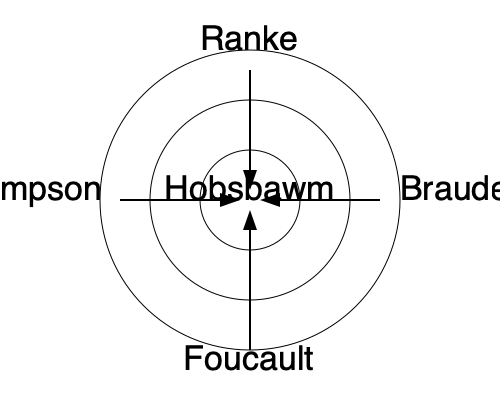Based on the network diagram of citations and influences, which historian appears to have had the most direct impact on Hobsbawm's work, and what does this suggest about the evolution of historical methodologies? To answer this question, we need to analyze the network diagram and consider the historical context of these historians:

1. The diagram shows five historians: Ranke, Braudel, Foucault, Thompson, and Hobsbawm.

2. Hobsbawm is placed at the center, indicating he is the focal point of our analysis.

3. Four arrows point towards Hobsbawm from the other historians, suggesting they all influenced his work to some degree.

4. The arrows are of different lengths, with the shortest coming from Ranke, indicating a more direct influence.

5. Leopold von Ranke (1795-1886) is considered the father of modern source-based history. His emphasis on primary sources and empirical research laid the foundation for scientific history.

6. Hobsbawm (1917-2012) was a Marxist historian known for his work on the "long 19th century" and his synthesis of social, economic, and political history.

7. The direct link between Ranke and Hobsbawm suggests that despite the temporal distance and ideological differences, Hobsbawm's work was still strongly rooted in Ranke's methodological approach to historical research.

8. This connection implies an evolution in historical methodologies where newer approaches (like Hobsbawm's Marxist interpretation) built upon, rather than entirely replaced, traditional source-based methods.

9. The influence of other historians (Braudel, Foucault, Thompson) on Hobsbawm indicates a synthesis of various historical approaches, including longue durée, discourse analysis, and social history, into Hobsbawm's work.

Therefore, based on the diagram, Ranke appears to have had the most direct impact on Hobsbawm's work. This suggests that while historical methodologies evolved to incorporate new perspectives and approaches, they continued to build upon the foundational principles of source-based research established by early modern historians like Ranke.
Answer: Ranke; evolution of historical methods built upon, rather than replaced, traditional source-based approaches. 